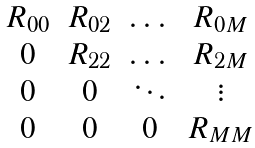<formula> <loc_0><loc_0><loc_500><loc_500>\begin{matrix} R _ { 0 0 } & R _ { 0 2 } & \dots & R _ { 0 M } \\ 0 & R _ { 2 2 } & \dots & R _ { 2 M } \\ 0 & 0 & \ddots & \vdots \\ 0 & 0 & 0 & R _ { M M } \end{matrix}</formula> 